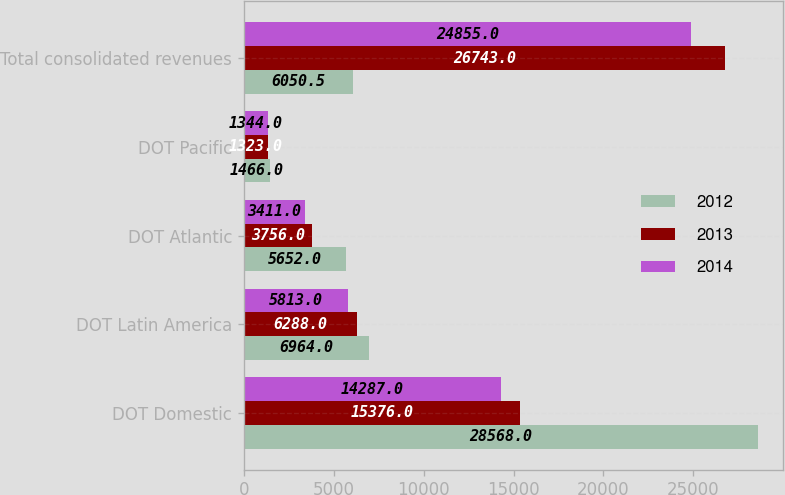<chart> <loc_0><loc_0><loc_500><loc_500><stacked_bar_chart><ecel><fcel>DOT Domestic<fcel>DOT Latin America<fcel>DOT Atlantic<fcel>DOT Pacific<fcel>Total consolidated revenues<nl><fcel>2012<fcel>28568<fcel>6964<fcel>5652<fcel>1466<fcel>6050.5<nl><fcel>2013<fcel>15376<fcel>6288<fcel>3756<fcel>1323<fcel>26743<nl><fcel>2014<fcel>14287<fcel>5813<fcel>3411<fcel>1344<fcel>24855<nl></chart> 